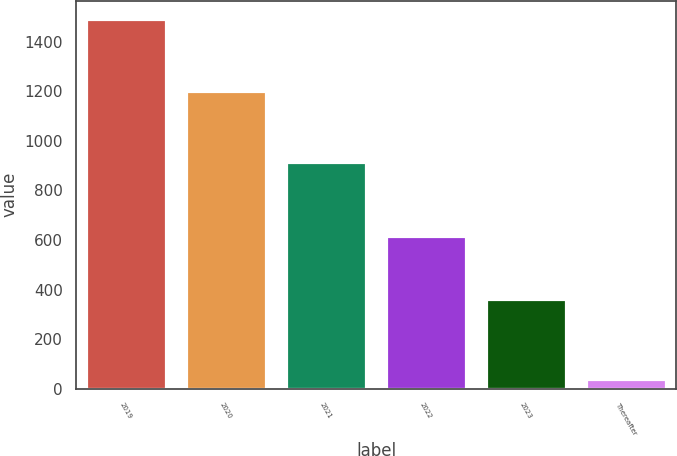<chart> <loc_0><loc_0><loc_500><loc_500><bar_chart><fcel>2019<fcel>2020<fcel>2021<fcel>2022<fcel>2023<fcel>Thereafter<nl><fcel>1491.1<fcel>1203.1<fcel>916.1<fcel>616.6<fcel>363.4<fcel>40.2<nl></chart> 